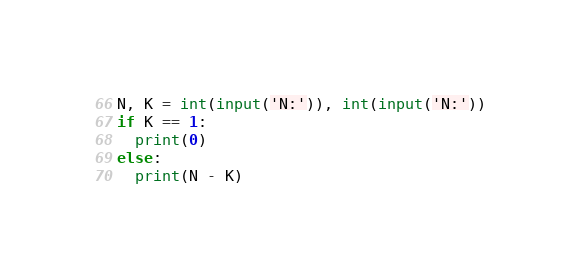Convert code to text. <code><loc_0><loc_0><loc_500><loc_500><_Python_>N, K = int(input('N:')), int(input('N:'))
if K == 1:
  print(0)
else:
  print(N - K)</code> 